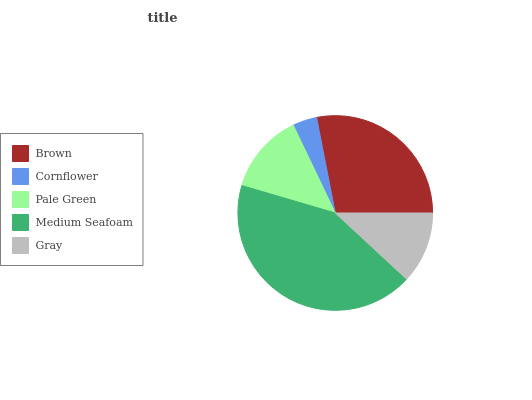Is Cornflower the minimum?
Answer yes or no. Yes. Is Medium Seafoam the maximum?
Answer yes or no. Yes. Is Pale Green the minimum?
Answer yes or no. No. Is Pale Green the maximum?
Answer yes or no. No. Is Pale Green greater than Cornflower?
Answer yes or no. Yes. Is Cornflower less than Pale Green?
Answer yes or no. Yes. Is Cornflower greater than Pale Green?
Answer yes or no. No. Is Pale Green less than Cornflower?
Answer yes or no. No. Is Pale Green the high median?
Answer yes or no. Yes. Is Pale Green the low median?
Answer yes or no. Yes. Is Cornflower the high median?
Answer yes or no. No. Is Brown the low median?
Answer yes or no. No. 